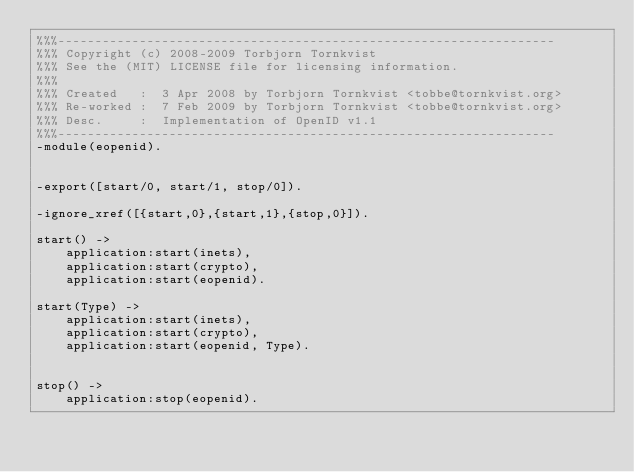Convert code to text. <code><loc_0><loc_0><loc_500><loc_500><_Erlang_>%%%-------------------------------------------------------------------
%%% Copyright (c) 2008-2009 Torbjorn Tornkvist
%%% See the (MIT) LICENSE file for licensing information.
%%%
%%% Created   :  3 Apr 2008 by Torbjorn Tornkvist <tobbe@tornkvist.org>
%%% Re-worked :  7 Feb 2009 by Torbjorn Tornkvist <tobbe@tornkvist.org>
%%% Desc.     :  Implementation of OpenID v1.1 
%%%-------------------------------------------------------------------
-module(eopenid).


-export([start/0, start/1, stop/0]).

-ignore_xref([{start,0},{start,1},{stop,0}]).

start() ->
    application:start(inets),
    application:start(crypto),
    application:start(eopenid).

start(Type) ->
    application:start(inets),
    application:start(crypto),
    application:start(eopenid, Type).


stop() ->
    application:stop(eopenid).
</code> 